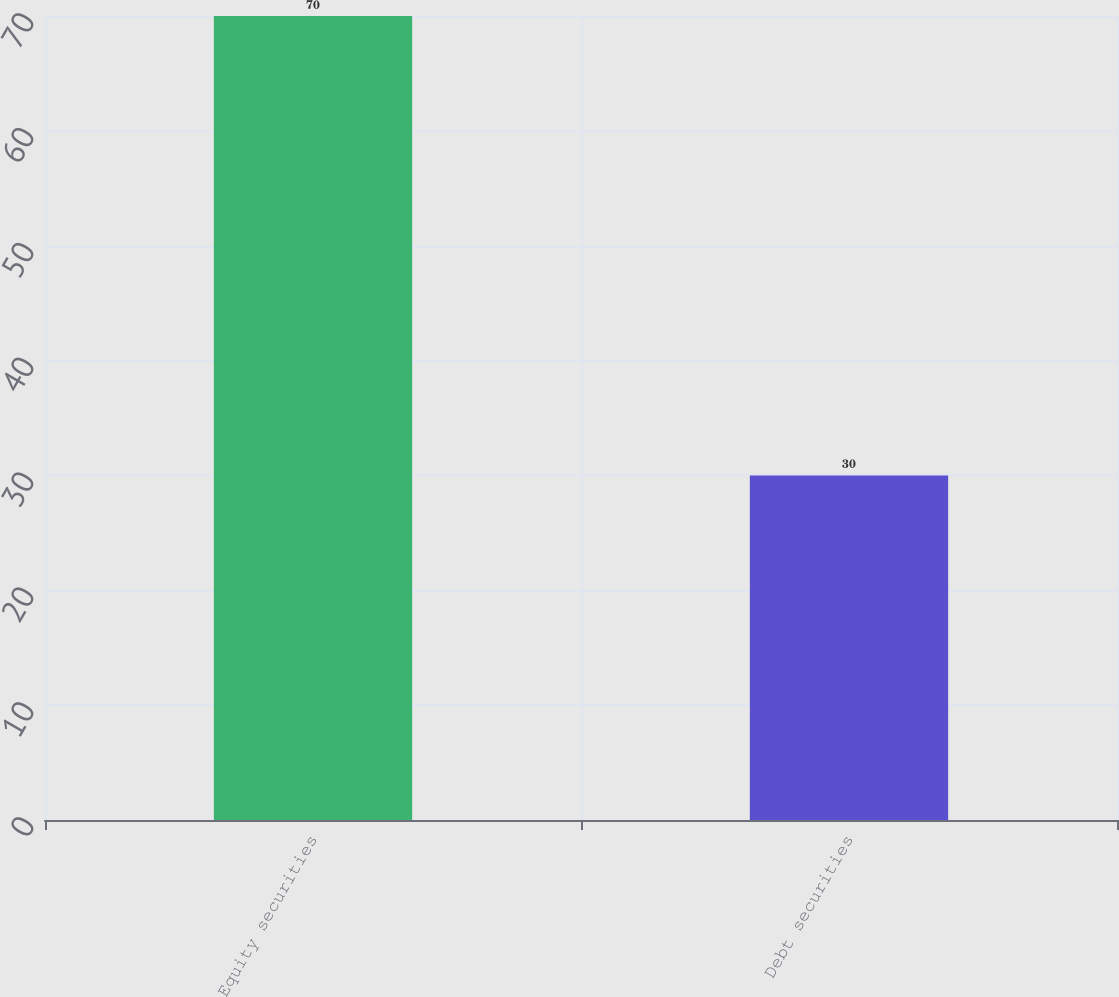<chart> <loc_0><loc_0><loc_500><loc_500><bar_chart><fcel>Equity securities<fcel>Debt securities<nl><fcel>70<fcel>30<nl></chart> 